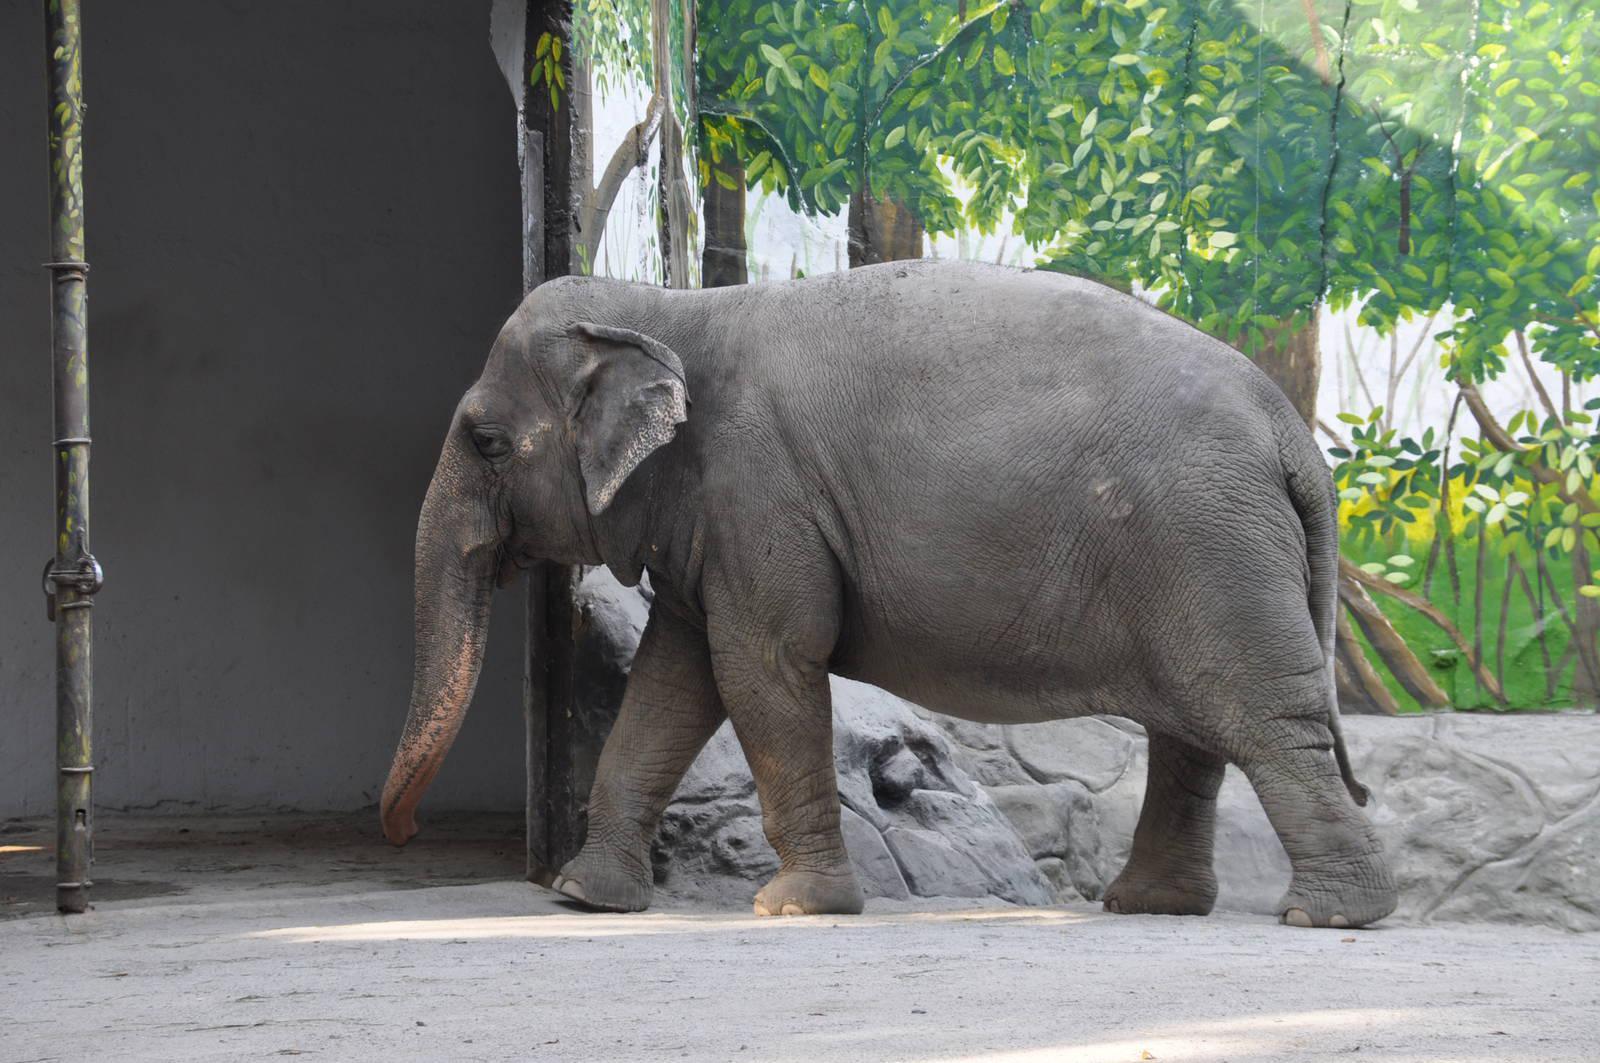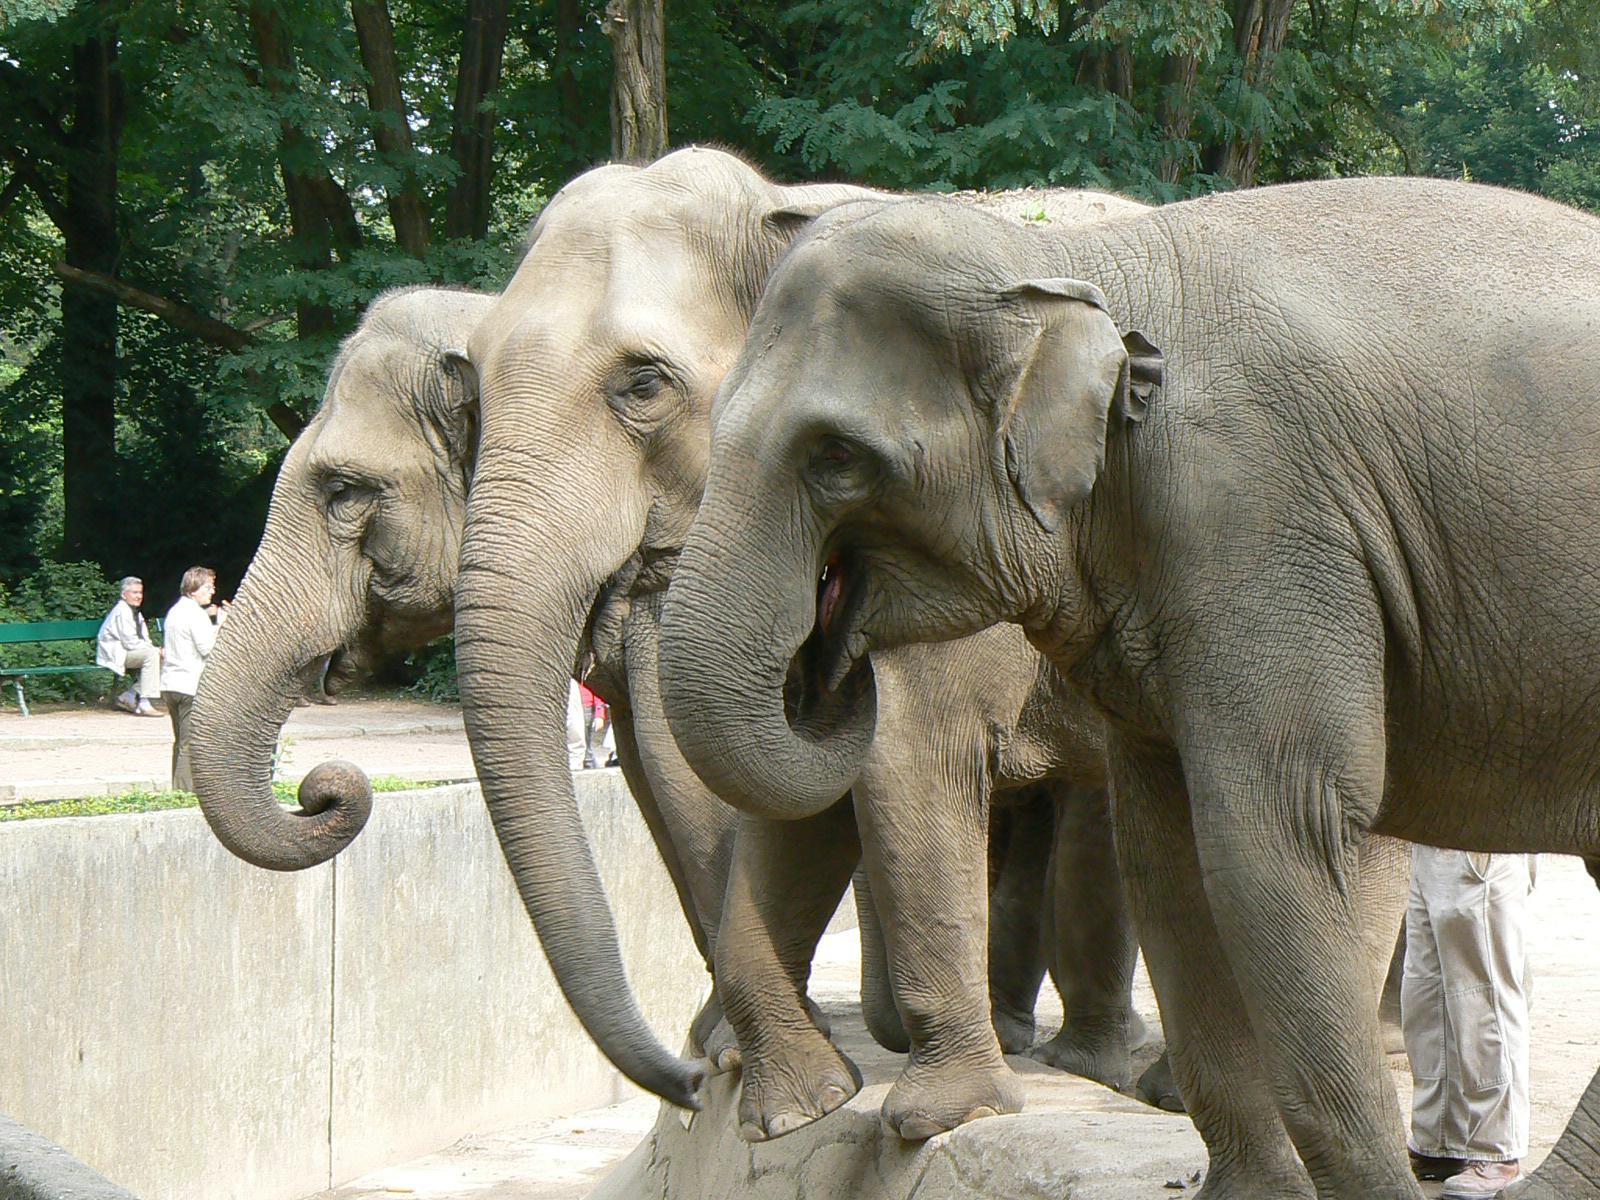The first image is the image on the left, the second image is the image on the right. For the images shown, is this caption "There are the same number of elephants in both images." true? Answer yes or no. No. The first image is the image on the left, the second image is the image on the right. For the images displayed, is the sentence "There's at least three elephants." factually correct? Answer yes or no. Yes. 